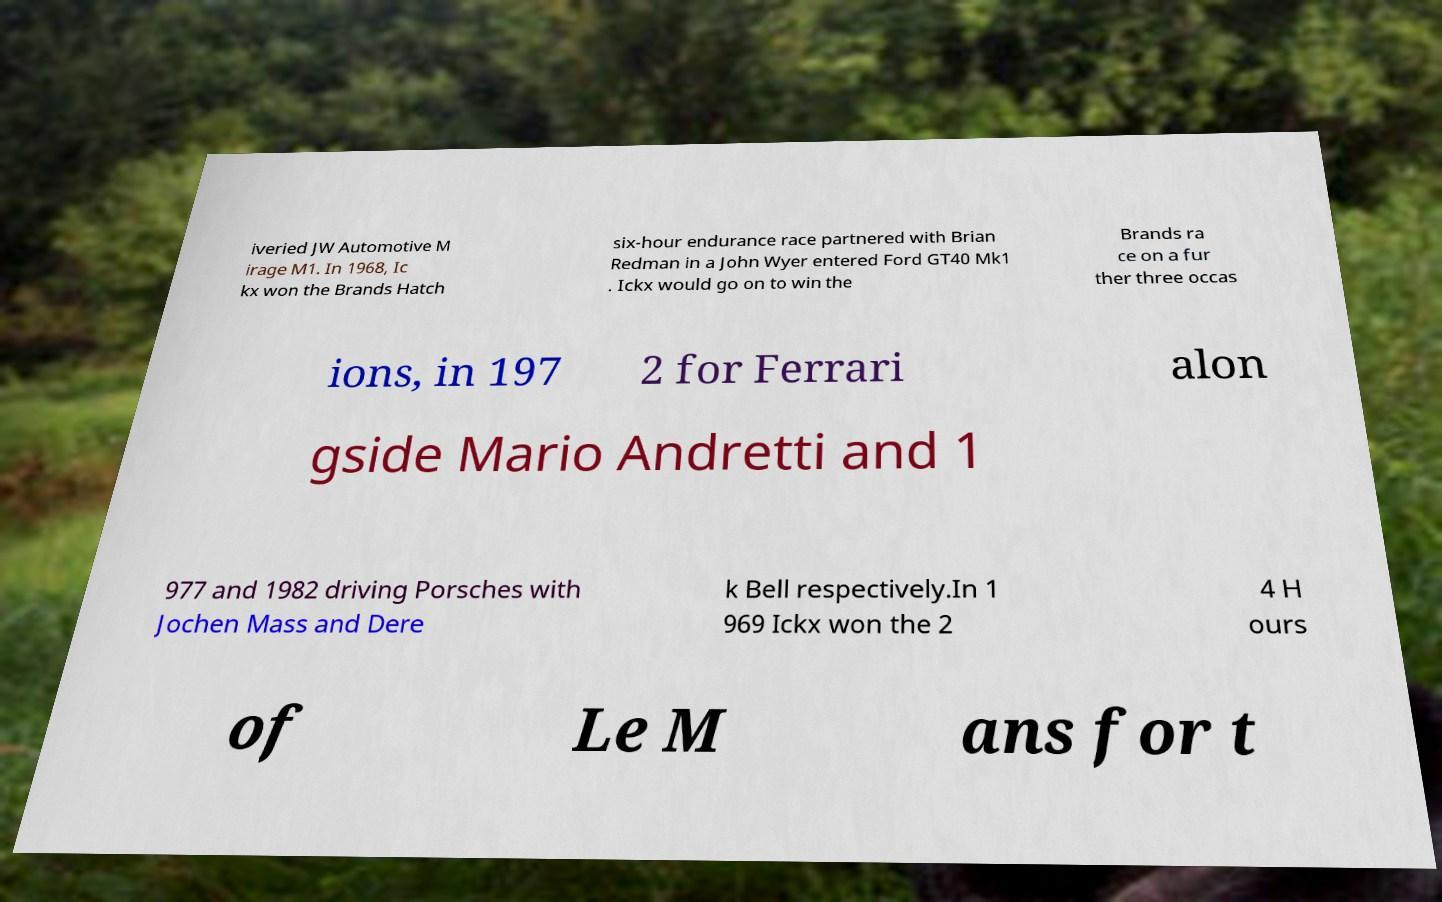Can you accurately transcribe the text from the provided image for me? iveried JW Automotive M irage M1. In 1968, Ic kx won the Brands Hatch six-hour endurance race partnered with Brian Redman in a John Wyer entered Ford GT40 Mk1 . Ickx would go on to win the Brands ra ce on a fur ther three occas ions, in 197 2 for Ferrari alon gside Mario Andretti and 1 977 and 1982 driving Porsches with Jochen Mass and Dere k Bell respectively.In 1 969 Ickx won the 2 4 H ours of Le M ans for t 